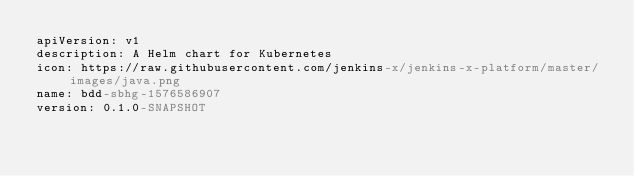<code> <loc_0><loc_0><loc_500><loc_500><_YAML_>apiVersion: v1
description: A Helm chart for Kubernetes
icon: https://raw.githubusercontent.com/jenkins-x/jenkins-x-platform/master/images/java.png
name: bdd-sbhg-1576586907
version: 0.1.0-SNAPSHOT
</code> 